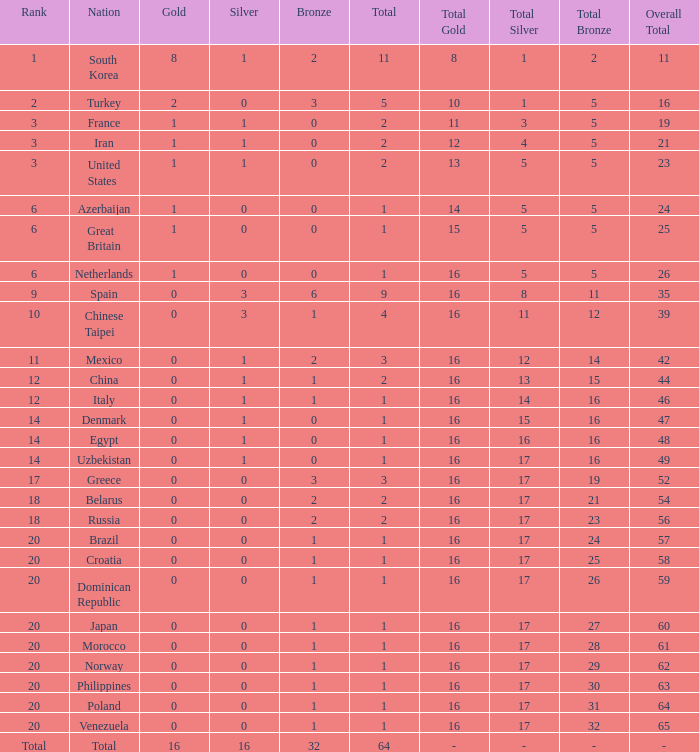What is the average number of bronze medals of the Philippines, which has more than 0 gold? None. 